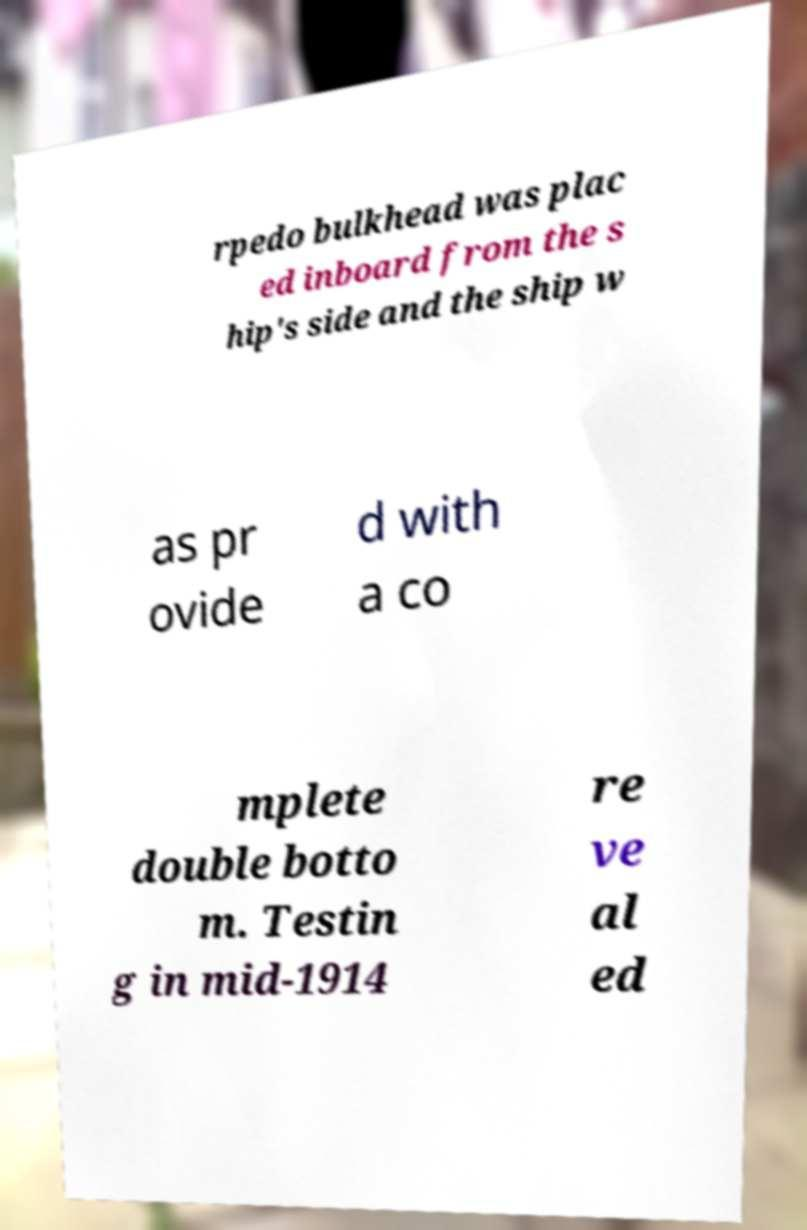Could you assist in decoding the text presented in this image and type it out clearly? rpedo bulkhead was plac ed inboard from the s hip's side and the ship w as pr ovide d with a co mplete double botto m. Testin g in mid-1914 re ve al ed 